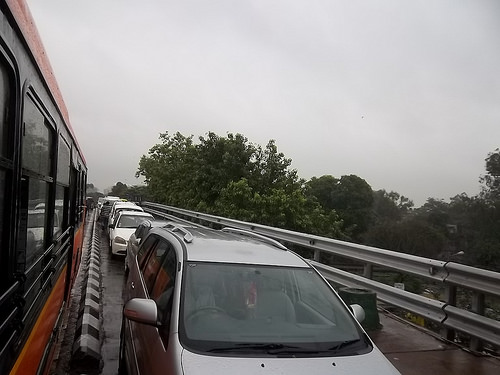<image>
Is the car on the bridge? Yes. Looking at the image, I can see the car is positioned on top of the bridge, with the bridge providing support. 